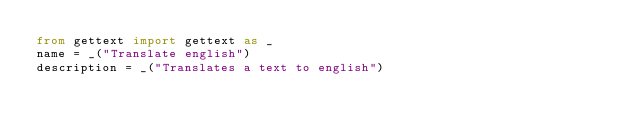<code> <loc_0><loc_0><loc_500><loc_500><_Python_>from gettext import gettext as _
name = _("Translate english")
description = _("Translates a text to english")
</code> 